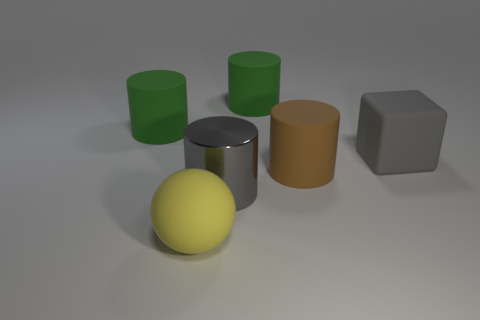Is there any other thing that has the same material as the gray cylinder?
Ensure brevity in your answer.  No. There is a large thing that is in front of the gray cylinder; does it have the same color as the metallic cylinder?
Offer a terse response. No. There is a gray thing that is the same shape as the brown object; what size is it?
Offer a very short reply. Large. The matte cylinder right of the object behind the large rubber object to the left of the big ball is what color?
Offer a terse response. Brown. Does the big ball have the same material as the big gray block?
Offer a terse response. Yes. There is a gray object that is in front of the big thing that is on the right side of the brown cylinder; are there any green matte objects on the right side of it?
Ensure brevity in your answer.  Yes. Do the shiny thing and the matte ball have the same color?
Your answer should be compact. No. Are there fewer large yellow things than big brown shiny objects?
Your answer should be very brief. No. Is the large green thing left of the ball made of the same material as the large gray cube that is behind the big shiny object?
Your answer should be compact. Yes. Is the number of big yellow matte balls that are to the right of the large brown cylinder less than the number of yellow spheres?
Your response must be concise. Yes. 